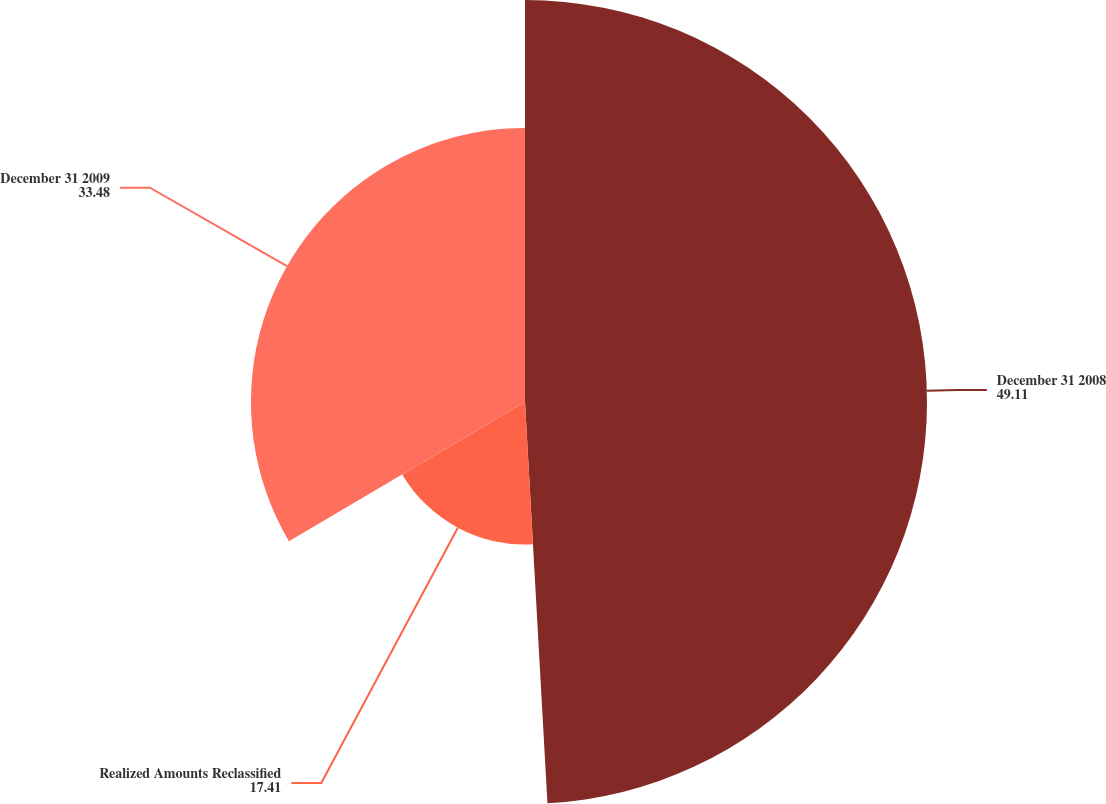<chart> <loc_0><loc_0><loc_500><loc_500><pie_chart><fcel>December 31 2008<fcel>Realized Amounts Reclassified<fcel>December 31 2009<nl><fcel>49.11%<fcel>17.41%<fcel>33.48%<nl></chart> 